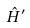Convert formula to latex. <formula><loc_0><loc_0><loc_500><loc_500>\hat { H } ^ { \prime }</formula> 